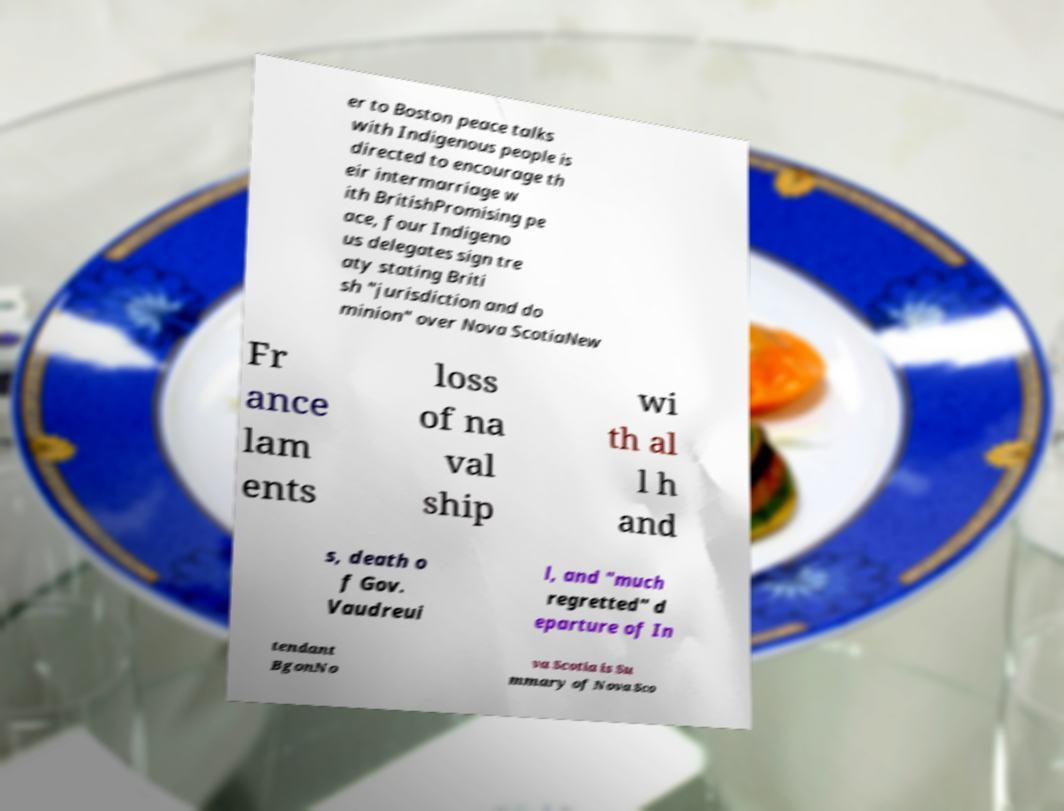What messages or text are displayed in this image? I need them in a readable, typed format. er to Boston peace talks with Indigenous people is directed to encourage th eir intermarriage w ith BritishPromising pe ace, four Indigeno us delegates sign tre aty stating Briti sh "jurisdiction and do minion" over Nova ScotiaNew Fr ance lam ents loss of na val ship wi th al l h and s, death o f Gov. Vaudreui l, and "much regretted" d eparture of In tendant BgonNo va Scotia is Su mmary of Nova Sco 